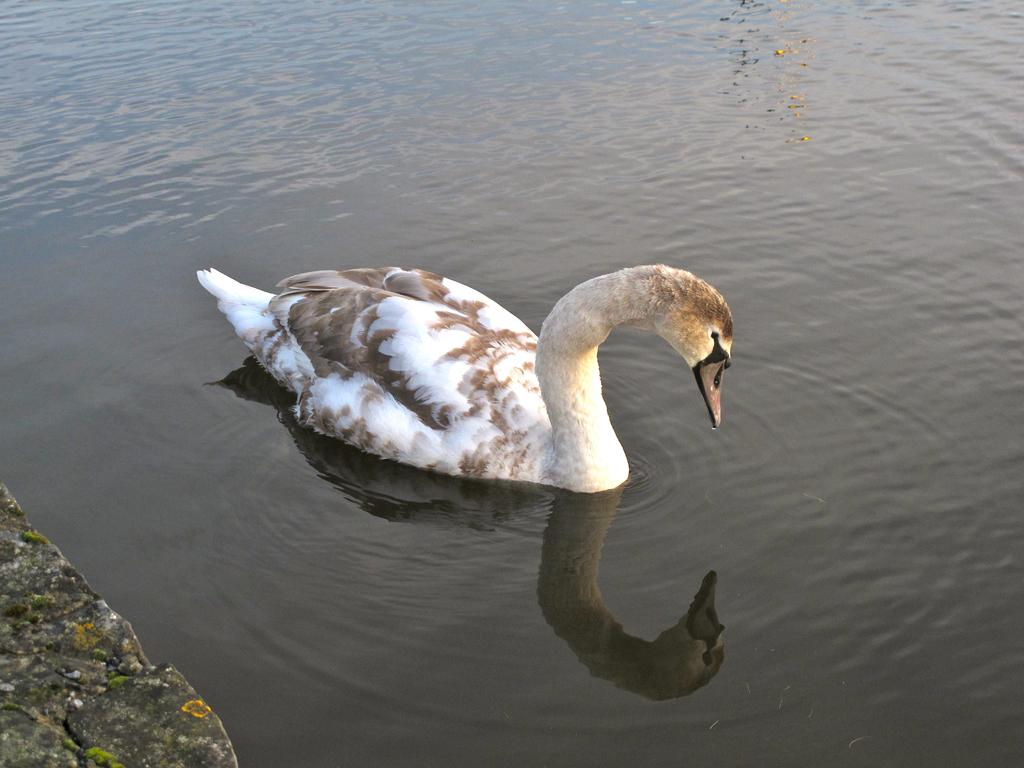What type of animal is in the image? There is a mallard in the image. What colors can be seen on the mallard? The mallard is in brown and white colors. Where is the mallard located in the image? The mallard is on the water. What can be seen in the left corner of the image? There is a fence in the left corner of the image. How much debt does the mallard have in the image? There is no indication of debt in the image, as it features a mallard on the water and a fence in the left corner. 